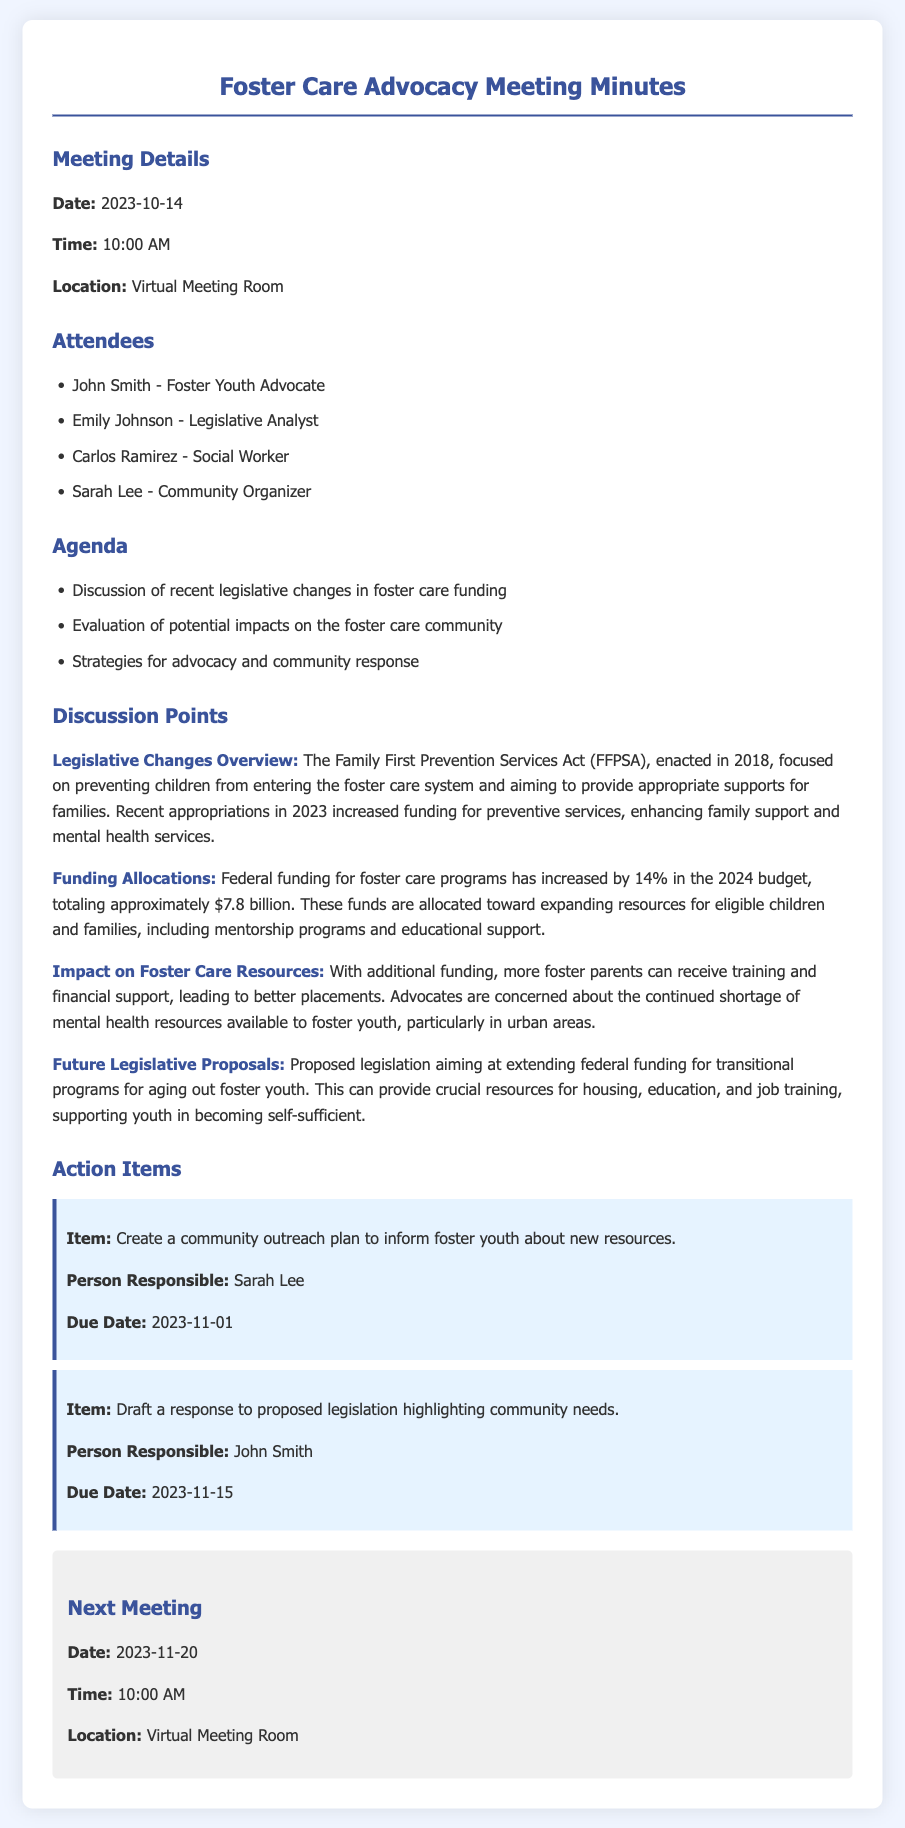What is the date of the meeting? The date is explicitly stated in the meeting details section of the document.
Answer: 2023-10-14 Who is the person responsible for the community outreach plan? The action items section specifies the individual assigned to the task.
Answer: Sarah Lee What percentage increase in federal funding for foster care programs is noted? The discussion points provide a specific percentage increase for the budget allocation.
Answer: 14% What is the total amount of funding for foster care programs in the 2024 budget? The document states the exact amount allocated for foster care resources.
Answer: $7.8 billion What legislation focuses on preventing children from entering the foster care system? The overview in the document mentions the specific act related to this focus.
Answer: Family First Prevention Services Act What is the due date for the response draft to proposed legislation? The action items include a specific due date for this task.
Answer: 2023-11-15 Why are advocates concerned despite the increase in funding? The discussion points highlight a continuing issue regarding resource availability related to mental health.
Answer: Mental health resources What will be discussed in the next meeting? The mention of topics to be addressed can indicate the focus of the following meeting.
Answer: Community needs and resources 